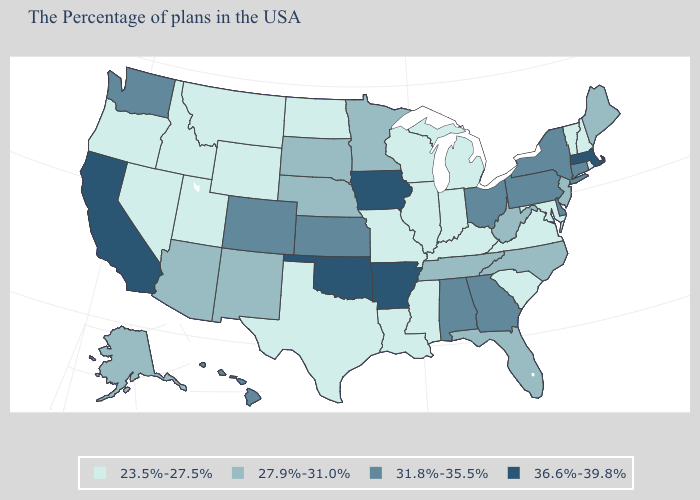Name the states that have a value in the range 36.6%-39.8%?
Write a very short answer. Massachusetts, Arkansas, Iowa, Oklahoma, California. Does the first symbol in the legend represent the smallest category?
Concise answer only. Yes. Does New York have the same value as West Virginia?
Give a very brief answer. No. Name the states that have a value in the range 27.9%-31.0%?
Write a very short answer. Maine, New Jersey, North Carolina, West Virginia, Florida, Tennessee, Minnesota, Nebraska, South Dakota, New Mexico, Arizona, Alaska. What is the highest value in the South ?
Short answer required. 36.6%-39.8%. Name the states that have a value in the range 31.8%-35.5%?
Quick response, please. Connecticut, New York, Delaware, Pennsylvania, Ohio, Georgia, Alabama, Kansas, Colorado, Washington, Hawaii. Does South Dakota have a higher value than Arizona?
Give a very brief answer. No. Does Georgia have a higher value than New Hampshire?
Concise answer only. Yes. What is the highest value in the USA?
Concise answer only. 36.6%-39.8%. Name the states that have a value in the range 23.5%-27.5%?
Quick response, please. Rhode Island, New Hampshire, Vermont, Maryland, Virginia, South Carolina, Michigan, Kentucky, Indiana, Wisconsin, Illinois, Mississippi, Louisiana, Missouri, Texas, North Dakota, Wyoming, Utah, Montana, Idaho, Nevada, Oregon. What is the value of Connecticut?
Concise answer only. 31.8%-35.5%. Is the legend a continuous bar?
Concise answer only. No. What is the highest value in the MidWest ?
Give a very brief answer. 36.6%-39.8%. Does Wisconsin have a lower value than Idaho?
Keep it brief. No. Name the states that have a value in the range 31.8%-35.5%?
Be succinct. Connecticut, New York, Delaware, Pennsylvania, Ohio, Georgia, Alabama, Kansas, Colorado, Washington, Hawaii. 